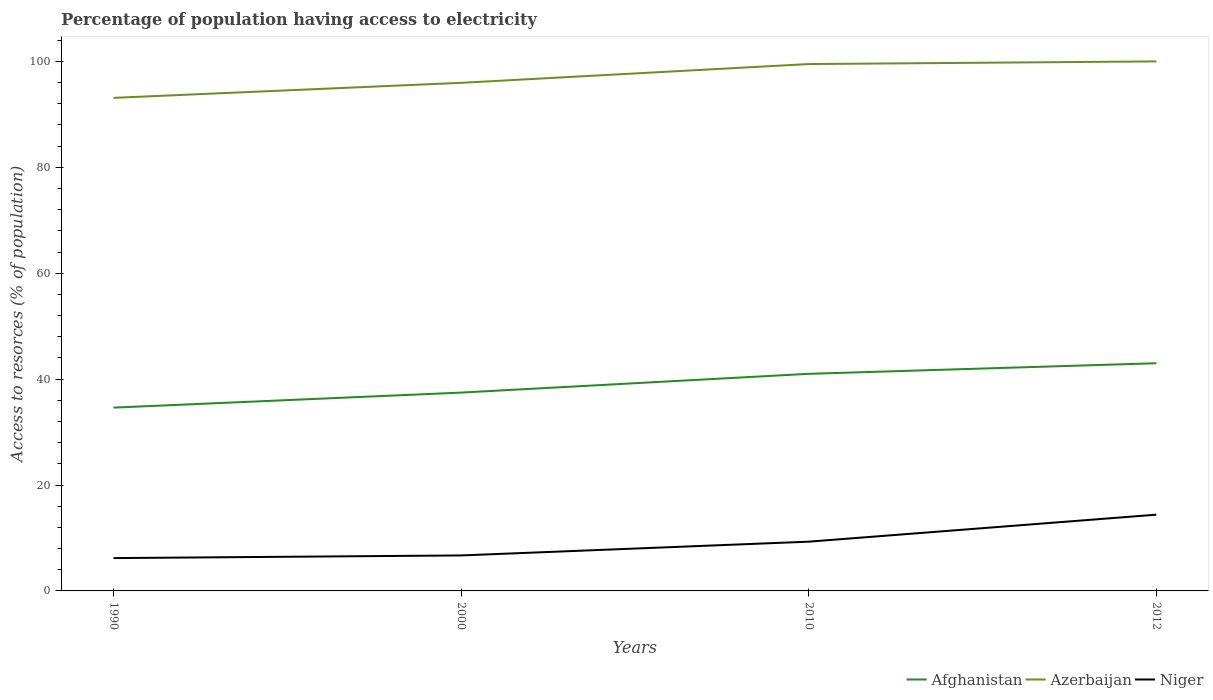Does the line corresponding to Niger intersect with the line corresponding to Azerbaijan?
Your answer should be very brief. No. Is the number of lines equal to the number of legend labels?
Offer a terse response. Yes. Across all years, what is the maximum percentage of population having access to electricity in Azerbaijan?
Ensure brevity in your answer.  93.12. What is the difference between the highest and the second highest percentage of population having access to electricity in Azerbaijan?
Give a very brief answer. 6.88. Is the percentage of population having access to electricity in Niger strictly greater than the percentage of population having access to electricity in Afghanistan over the years?
Your answer should be compact. Yes. Does the graph contain any zero values?
Your answer should be very brief. No. Where does the legend appear in the graph?
Your answer should be very brief. Bottom right. What is the title of the graph?
Offer a very short reply. Percentage of population having access to electricity. Does "Pakistan" appear as one of the legend labels in the graph?
Your response must be concise. No. What is the label or title of the Y-axis?
Your answer should be very brief. Access to resorces (% of population). What is the Access to resorces (% of population) of Afghanistan in 1990?
Offer a terse response. 34.62. What is the Access to resorces (% of population) of Azerbaijan in 1990?
Your answer should be compact. 93.12. What is the Access to resorces (% of population) in Niger in 1990?
Give a very brief answer. 6.2. What is the Access to resorces (% of population) of Afghanistan in 2000?
Offer a terse response. 37.46. What is the Access to resorces (% of population) of Azerbaijan in 2000?
Offer a terse response. 95.96. What is the Access to resorces (% of population) of Niger in 2000?
Provide a succinct answer. 6.7. What is the Access to resorces (% of population) of Afghanistan in 2010?
Ensure brevity in your answer.  41. What is the Access to resorces (% of population) of Azerbaijan in 2010?
Give a very brief answer. 99.5. What is the Access to resorces (% of population) in Niger in 2010?
Your answer should be very brief. 9.3. Across all years, what is the maximum Access to resorces (% of population) in Azerbaijan?
Keep it short and to the point. 100. Across all years, what is the maximum Access to resorces (% of population) of Niger?
Your answer should be compact. 14.4. Across all years, what is the minimum Access to resorces (% of population) in Afghanistan?
Provide a short and direct response. 34.62. Across all years, what is the minimum Access to resorces (% of population) in Azerbaijan?
Your answer should be very brief. 93.12. What is the total Access to resorces (% of population) in Afghanistan in the graph?
Offer a terse response. 156.07. What is the total Access to resorces (% of population) of Azerbaijan in the graph?
Offer a very short reply. 388.57. What is the total Access to resorces (% of population) in Niger in the graph?
Offer a very short reply. 36.6. What is the difference between the Access to resorces (% of population) in Afghanistan in 1990 and that in 2000?
Your answer should be compact. -2.84. What is the difference between the Access to resorces (% of population) in Azerbaijan in 1990 and that in 2000?
Your answer should be compact. -2.84. What is the difference between the Access to resorces (% of population) in Afghanistan in 1990 and that in 2010?
Keep it short and to the point. -6.38. What is the difference between the Access to resorces (% of population) of Azerbaijan in 1990 and that in 2010?
Your answer should be compact. -6.38. What is the difference between the Access to resorces (% of population) in Niger in 1990 and that in 2010?
Your answer should be very brief. -3.1. What is the difference between the Access to resorces (% of population) in Afghanistan in 1990 and that in 2012?
Give a very brief answer. -8.38. What is the difference between the Access to resorces (% of population) in Azerbaijan in 1990 and that in 2012?
Make the answer very short. -6.88. What is the difference between the Access to resorces (% of population) of Afghanistan in 2000 and that in 2010?
Give a very brief answer. -3.54. What is the difference between the Access to resorces (% of population) of Azerbaijan in 2000 and that in 2010?
Your response must be concise. -3.54. What is the difference between the Access to resorces (% of population) in Niger in 2000 and that in 2010?
Provide a short and direct response. -2.6. What is the difference between the Access to resorces (% of population) in Afghanistan in 2000 and that in 2012?
Ensure brevity in your answer.  -5.54. What is the difference between the Access to resorces (% of population) in Azerbaijan in 2000 and that in 2012?
Provide a succinct answer. -4.04. What is the difference between the Access to resorces (% of population) in Afghanistan in 1990 and the Access to resorces (% of population) in Azerbaijan in 2000?
Offer a very short reply. -61.34. What is the difference between the Access to resorces (% of population) in Afghanistan in 1990 and the Access to resorces (% of population) in Niger in 2000?
Ensure brevity in your answer.  27.92. What is the difference between the Access to resorces (% of population) in Azerbaijan in 1990 and the Access to resorces (% of population) in Niger in 2000?
Your answer should be compact. 86.42. What is the difference between the Access to resorces (% of population) of Afghanistan in 1990 and the Access to resorces (% of population) of Azerbaijan in 2010?
Your response must be concise. -64.88. What is the difference between the Access to resorces (% of population) of Afghanistan in 1990 and the Access to resorces (% of population) of Niger in 2010?
Keep it short and to the point. 25.32. What is the difference between the Access to resorces (% of population) in Azerbaijan in 1990 and the Access to resorces (% of population) in Niger in 2010?
Provide a succinct answer. 83.82. What is the difference between the Access to resorces (% of population) of Afghanistan in 1990 and the Access to resorces (% of population) of Azerbaijan in 2012?
Ensure brevity in your answer.  -65.38. What is the difference between the Access to resorces (% of population) of Afghanistan in 1990 and the Access to resorces (% of population) of Niger in 2012?
Your response must be concise. 20.22. What is the difference between the Access to resorces (% of population) in Azerbaijan in 1990 and the Access to resorces (% of population) in Niger in 2012?
Your answer should be compact. 78.72. What is the difference between the Access to resorces (% of population) in Afghanistan in 2000 and the Access to resorces (% of population) in Azerbaijan in 2010?
Make the answer very short. -62.04. What is the difference between the Access to resorces (% of population) of Afghanistan in 2000 and the Access to resorces (% of population) of Niger in 2010?
Keep it short and to the point. 28.16. What is the difference between the Access to resorces (% of population) of Azerbaijan in 2000 and the Access to resorces (% of population) of Niger in 2010?
Your response must be concise. 86.66. What is the difference between the Access to resorces (% of population) in Afghanistan in 2000 and the Access to resorces (% of population) in Azerbaijan in 2012?
Offer a very short reply. -62.54. What is the difference between the Access to resorces (% of population) in Afghanistan in 2000 and the Access to resorces (% of population) in Niger in 2012?
Offer a very short reply. 23.06. What is the difference between the Access to resorces (% of population) in Azerbaijan in 2000 and the Access to resorces (% of population) in Niger in 2012?
Your answer should be compact. 81.56. What is the difference between the Access to resorces (% of population) in Afghanistan in 2010 and the Access to resorces (% of population) in Azerbaijan in 2012?
Ensure brevity in your answer.  -59. What is the difference between the Access to resorces (% of population) of Afghanistan in 2010 and the Access to resorces (% of population) of Niger in 2012?
Your answer should be very brief. 26.6. What is the difference between the Access to resorces (% of population) in Azerbaijan in 2010 and the Access to resorces (% of population) in Niger in 2012?
Keep it short and to the point. 85.1. What is the average Access to resorces (% of population) of Afghanistan per year?
Your answer should be very brief. 39.02. What is the average Access to resorces (% of population) of Azerbaijan per year?
Your answer should be compact. 97.14. What is the average Access to resorces (% of population) of Niger per year?
Provide a succinct answer. 9.15. In the year 1990, what is the difference between the Access to resorces (% of population) in Afghanistan and Access to resorces (% of population) in Azerbaijan?
Ensure brevity in your answer.  -58.5. In the year 1990, what is the difference between the Access to resorces (% of population) in Afghanistan and Access to resorces (% of population) in Niger?
Make the answer very short. 28.42. In the year 1990, what is the difference between the Access to resorces (% of population) of Azerbaijan and Access to resorces (% of population) of Niger?
Give a very brief answer. 86.92. In the year 2000, what is the difference between the Access to resorces (% of population) of Afghanistan and Access to resorces (% of population) of Azerbaijan?
Offer a very short reply. -58.5. In the year 2000, what is the difference between the Access to resorces (% of population) of Afghanistan and Access to resorces (% of population) of Niger?
Make the answer very short. 30.76. In the year 2000, what is the difference between the Access to resorces (% of population) in Azerbaijan and Access to resorces (% of population) in Niger?
Your response must be concise. 89.26. In the year 2010, what is the difference between the Access to resorces (% of population) in Afghanistan and Access to resorces (% of population) in Azerbaijan?
Give a very brief answer. -58.5. In the year 2010, what is the difference between the Access to resorces (% of population) in Afghanistan and Access to resorces (% of population) in Niger?
Make the answer very short. 31.7. In the year 2010, what is the difference between the Access to resorces (% of population) of Azerbaijan and Access to resorces (% of population) of Niger?
Provide a succinct answer. 90.2. In the year 2012, what is the difference between the Access to resorces (% of population) in Afghanistan and Access to resorces (% of population) in Azerbaijan?
Provide a succinct answer. -57. In the year 2012, what is the difference between the Access to resorces (% of population) of Afghanistan and Access to resorces (% of population) of Niger?
Your response must be concise. 28.6. In the year 2012, what is the difference between the Access to resorces (% of population) of Azerbaijan and Access to resorces (% of population) of Niger?
Provide a succinct answer. 85.6. What is the ratio of the Access to resorces (% of population) in Afghanistan in 1990 to that in 2000?
Provide a succinct answer. 0.92. What is the ratio of the Access to resorces (% of population) in Azerbaijan in 1990 to that in 2000?
Provide a succinct answer. 0.97. What is the ratio of the Access to resorces (% of population) in Niger in 1990 to that in 2000?
Your answer should be very brief. 0.93. What is the ratio of the Access to resorces (% of population) of Afghanistan in 1990 to that in 2010?
Your answer should be very brief. 0.84. What is the ratio of the Access to resorces (% of population) in Azerbaijan in 1990 to that in 2010?
Your response must be concise. 0.94. What is the ratio of the Access to resorces (% of population) of Niger in 1990 to that in 2010?
Make the answer very short. 0.67. What is the ratio of the Access to resorces (% of population) of Afghanistan in 1990 to that in 2012?
Your answer should be compact. 0.81. What is the ratio of the Access to resorces (% of population) of Azerbaijan in 1990 to that in 2012?
Your response must be concise. 0.93. What is the ratio of the Access to resorces (% of population) in Niger in 1990 to that in 2012?
Make the answer very short. 0.43. What is the ratio of the Access to resorces (% of population) in Afghanistan in 2000 to that in 2010?
Ensure brevity in your answer.  0.91. What is the ratio of the Access to resorces (% of population) in Azerbaijan in 2000 to that in 2010?
Ensure brevity in your answer.  0.96. What is the ratio of the Access to resorces (% of population) in Niger in 2000 to that in 2010?
Provide a succinct answer. 0.72. What is the ratio of the Access to resorces (% of population) of Afghanistan in 2000 to that in 2012?
Your response must be concise. 0.87. What is the ratio of the Access to resorces (% of population) of Azerbaijan in 2000 to that in 2012?
Your answer should be compact. 0.96. What is the ratio of the Access to resorces (% of population) in Niger in 2000 to that in 2012?
Give a very brief answer. 0.47. What is the ratio of the Access to resorces (% of population) in Afghanistan in 2010 to that in 2012?
Ensure brevity in your answer.  0.95. What is the ratio of the Access to resorces (% of population) in Azerbaijan in 2010 to that in 2012?
Your answer should be very brief. 0.99. What is the ratio of the Access to resorces (% of population) in Niger in 2010 to that in 2012?
Give a very brief answer. 0.65. What is the difference between the highest and the second highest Access to resorces (% of population) in Niger?
Make the answer very short. 5.1. What is the difference between the highest and the lowest Access to resorces (% of population) in Afghanistan?
Keep it short and to the point. 8.38. What is the difference between the highest and the lowest Access to resorces (% of population) of Azerbaijan?
Make the answer very short. 6.88. 